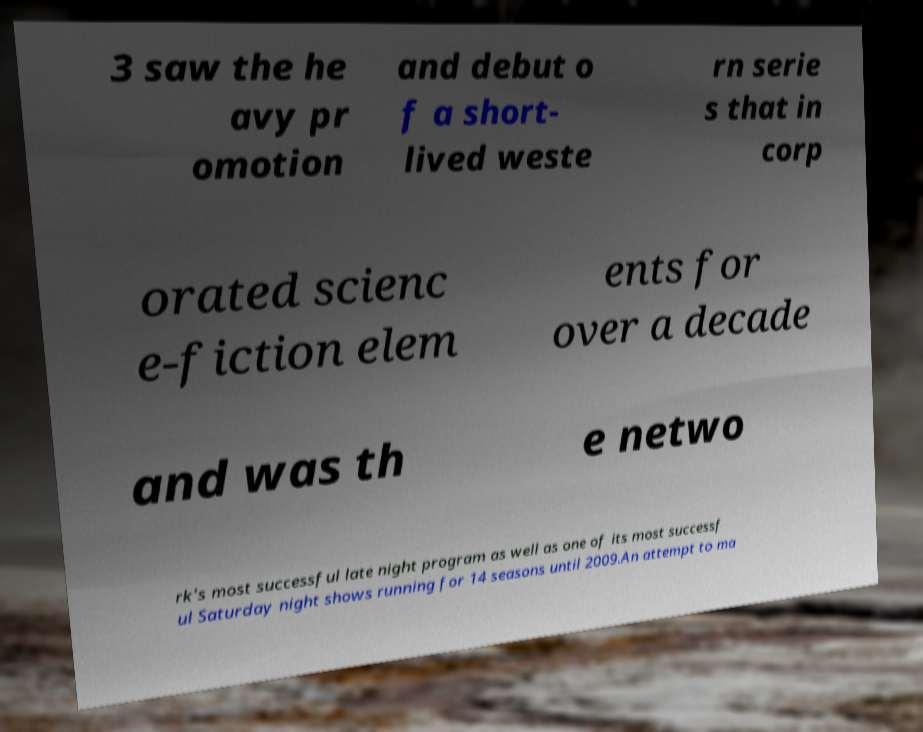Please read and relay the text visible in this image. What does it say? 3 saw the he avy pr omotion and debut o f a short- lived weste rn serie s that in corp orated scienc e-fiction elem ents for over a decade and was th e netwo rk's most successful late night program as well as one of its most successf ul Saturday night shows running for 14 seasons until 2009.An attempt to ma 